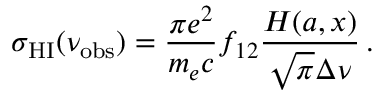Convert formula to latex. <formula><loc_0><loc_0><loc_500><loc_500>\sigma _ { H I } ( \nu _ { o b s } ) = \frac { \pi e ^ { 2 } } { m _ { e } c } f _ { 1 2 } \frac { H ( a , x ) } { \sqrt { \pi } \Delta \nu } \, .</formula> 